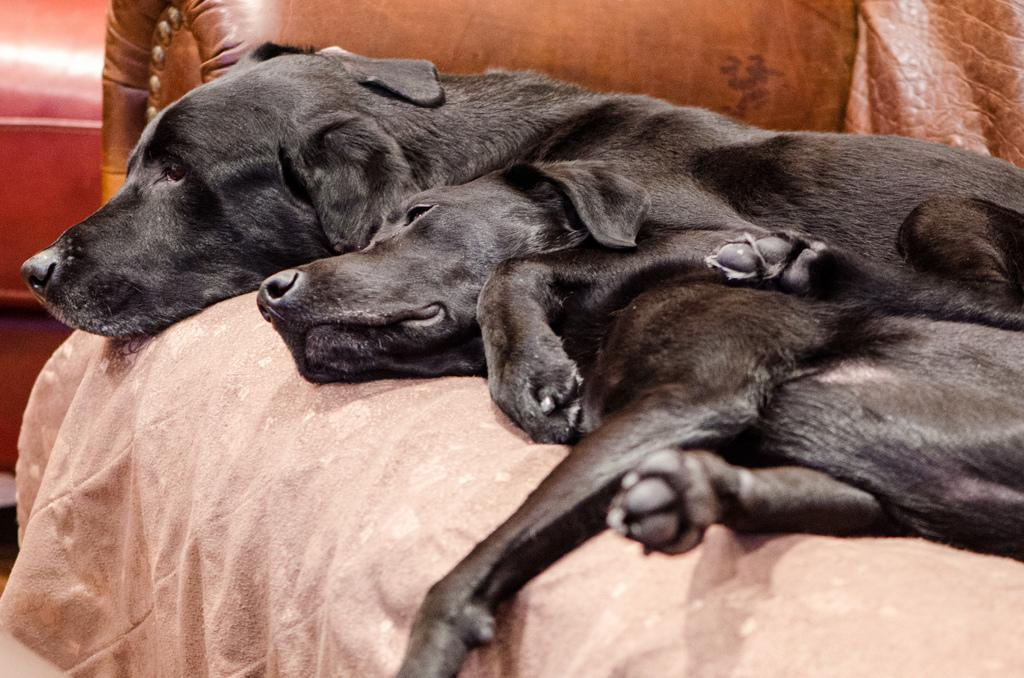How many dogs are present in the image? There are two dogs in the image. What is located at the bottom of the image? There is a bed at the bottom of the image. Can you describe the background of the image? There are objects visible in the background of the image. What type of muscle can be seen flexing in the image? There is no muscle visible in the image, as it features two dogs and a bed. 